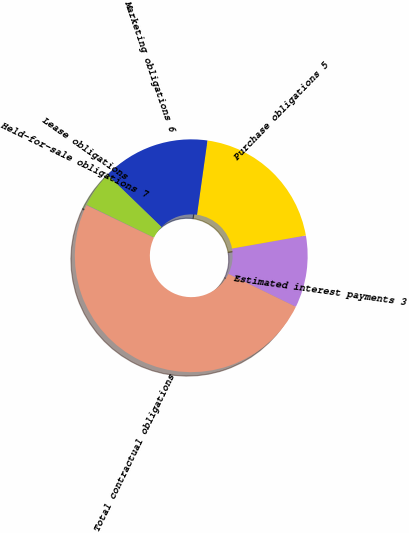Convert chart to OTSL. <chart><loc_0><loc_0><loc_500><loc_500><pie_chart><fcel>Estimated interest payments 3<fcel>Purchase obligations 5<fcel>Marketing obligations 6<fcel>Lease obligations<fcel>Held-for-sale obligations 7<fcel>Total contractual obligations<nl><fcel>10.02%<fcel>19.99%<fcel>15.0%<fcel>5.03%<fcel>0.04%<fcel>49.92%<nl></chart> 